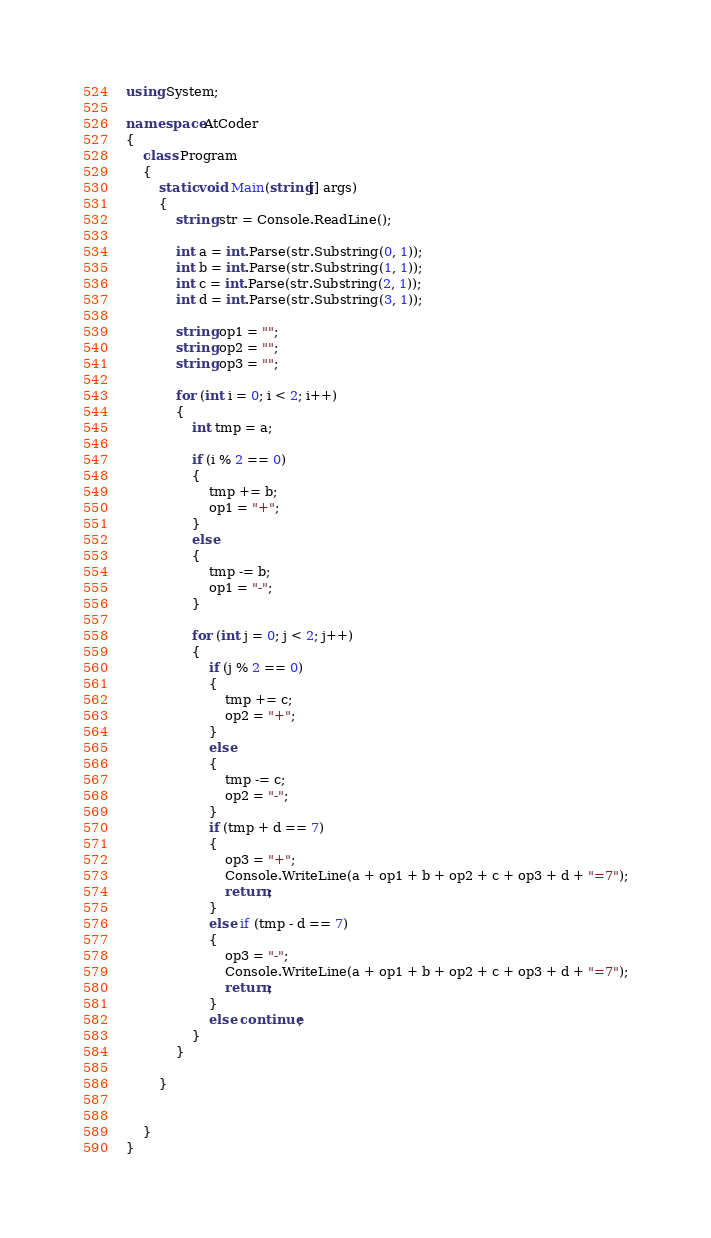Convert code to text. <code><loc_0><loc_0><loc_500><loc_500><_C#_>using System;

namespace AtCoder
{
	class Program
	{
		static void Main(string[] args)
		{
			string str = Console.ReadLine();

			int a = int.Parse(str.Substring(0, 1));
			int b = int.Parse(str.Substring(1, 1));
			int c = int.Parse(str.Substring(2, 1));
			int d = int.Parse(str.Substring(3, 1));

			string op1 = "";
			string op2 = "";
			string op3 = "";

			for (int i = 0; i < 2; i++)
			{
				int tmp = a;

				if (i % 2 == 0)
				{
					tmp += b;
					op1 = "+";
				}
				else
				{
					tmp -= b;
					op1 = "-";
				}

				for (int j = 0; j < 2; j++)
				{
					if (j % 2 == 0)
					{
						tmp += c;
						op2 = "+";
					}
					else
					{
						tmp -= c;
						op2 = "-";
					}
					if (tmp + d == 7)
					{
						op3 = "+";
						Console.WriteLine(a + op1 + b + op2 + c + op3 + d + "=7");
						return;
					}
					else if (tmp - d == 7)
					{
						op3 = "-";
						Console.WriteLine(a + op1 + b + op2 + c + op3 + d + "=7");
						return;
					}
					else continue;
				}
			}

		}


	}
}
</code> 